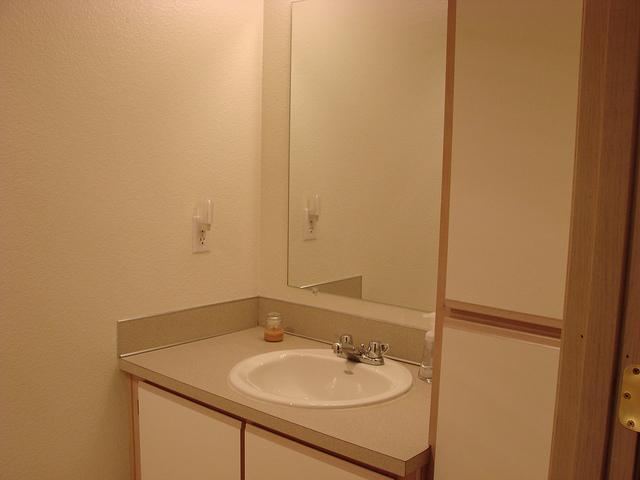How many people are wearing an orange shirt in this image?
Give a very brief answer. 0. 